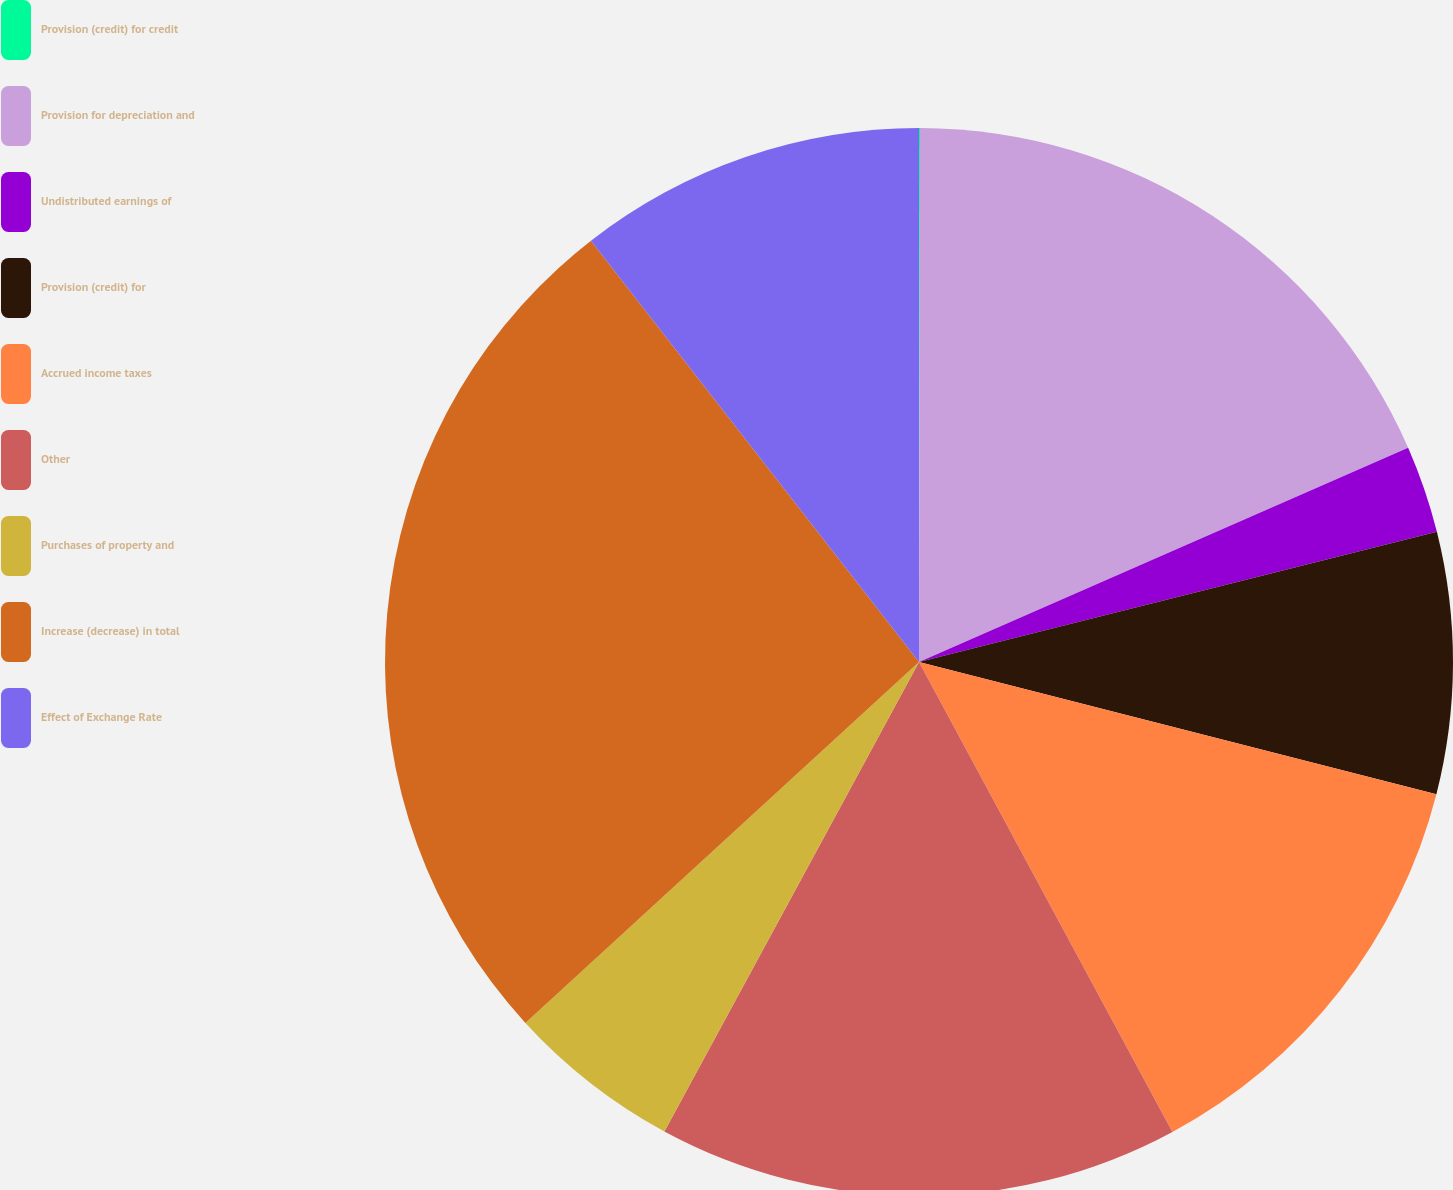<chart> <loc_0><loc_0><loc_500><loc_500><pie_chart><fcel>Provision (credit) for credit<fcel>Provision for depreciation and<fcel>Undistributed earnings of<fcel>Provision (credit) for<fcel>Accrued income taxes<fcel>Other<fcel>Purchases of property and<fcel>Increase (decrease) in total<fcel>Effect of Exchange Rate<nl><fcel>0.03%<fcel>18.4%<fcel>2.65%<fcel>7.9%<fcel>13.15%<fcel>15.78%<fcel>5.28%<fcel>26.28%<fcel>10.53%<nl></chart> 